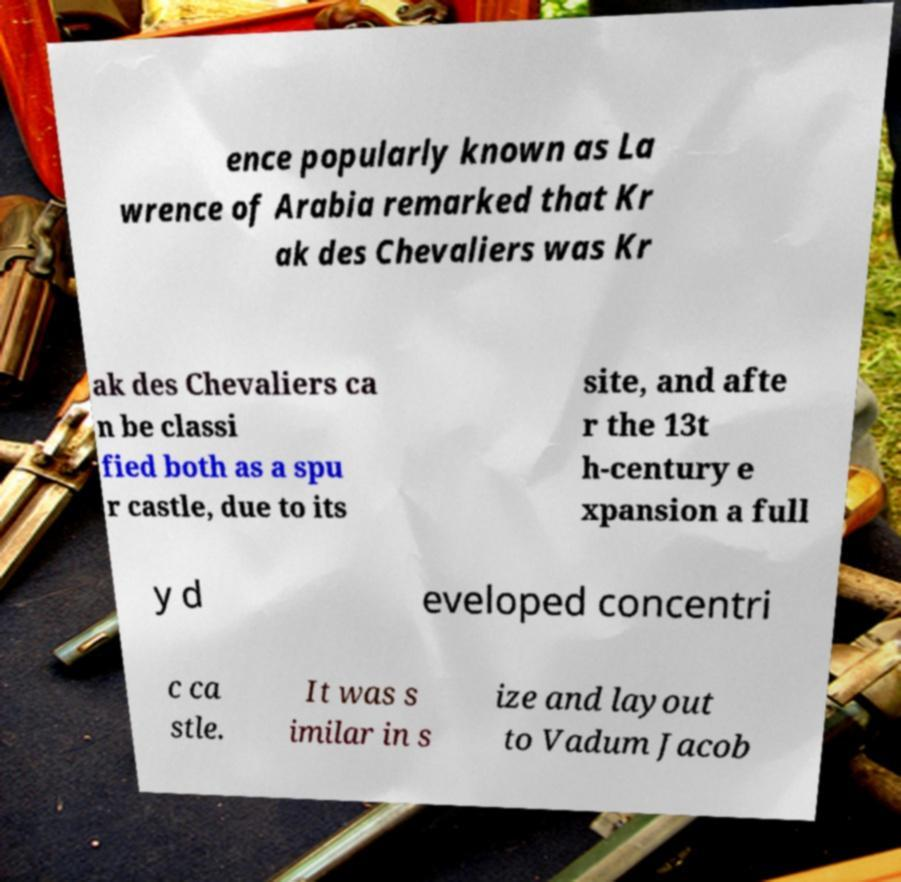Can you read and provide the text displayed in the image?This photo seems to have some interesting text. Can you extract and type it out for me? ence popularly known as La wrence of Arabia remarked that Kr ak des Chevaliers was Kr ak des Chevaliers ca n be classi fied both as a spu r castle, due to its site, and afte r the 13t h-century e xpansion a full y d eveloped concentri c ca stle. It was s imilar in s ize and layout to Vadum Jacob 